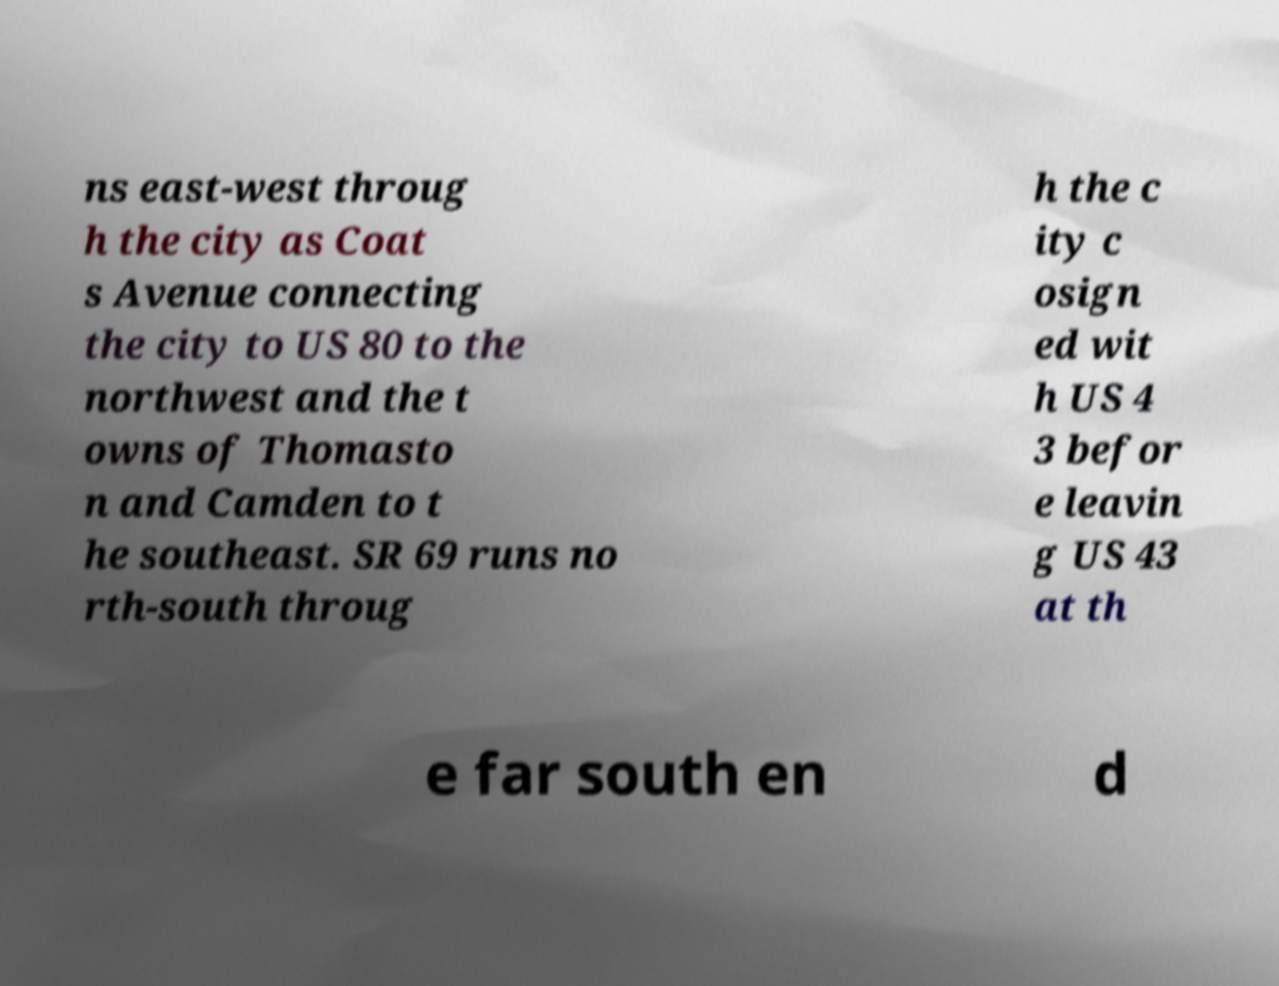What messages or text are displayed in this image? I need them in a readable, typed format. ns east-west throug h the city as Coat s Avenue connecting the city to US 80 to the northwest and the t owns of Thomasto n and Camden to t he southeast. SR 69 runs no rth-south throug h the c ity c osign ed wit h US 4 3 befor e leavin g US 43 at th e far south en d 